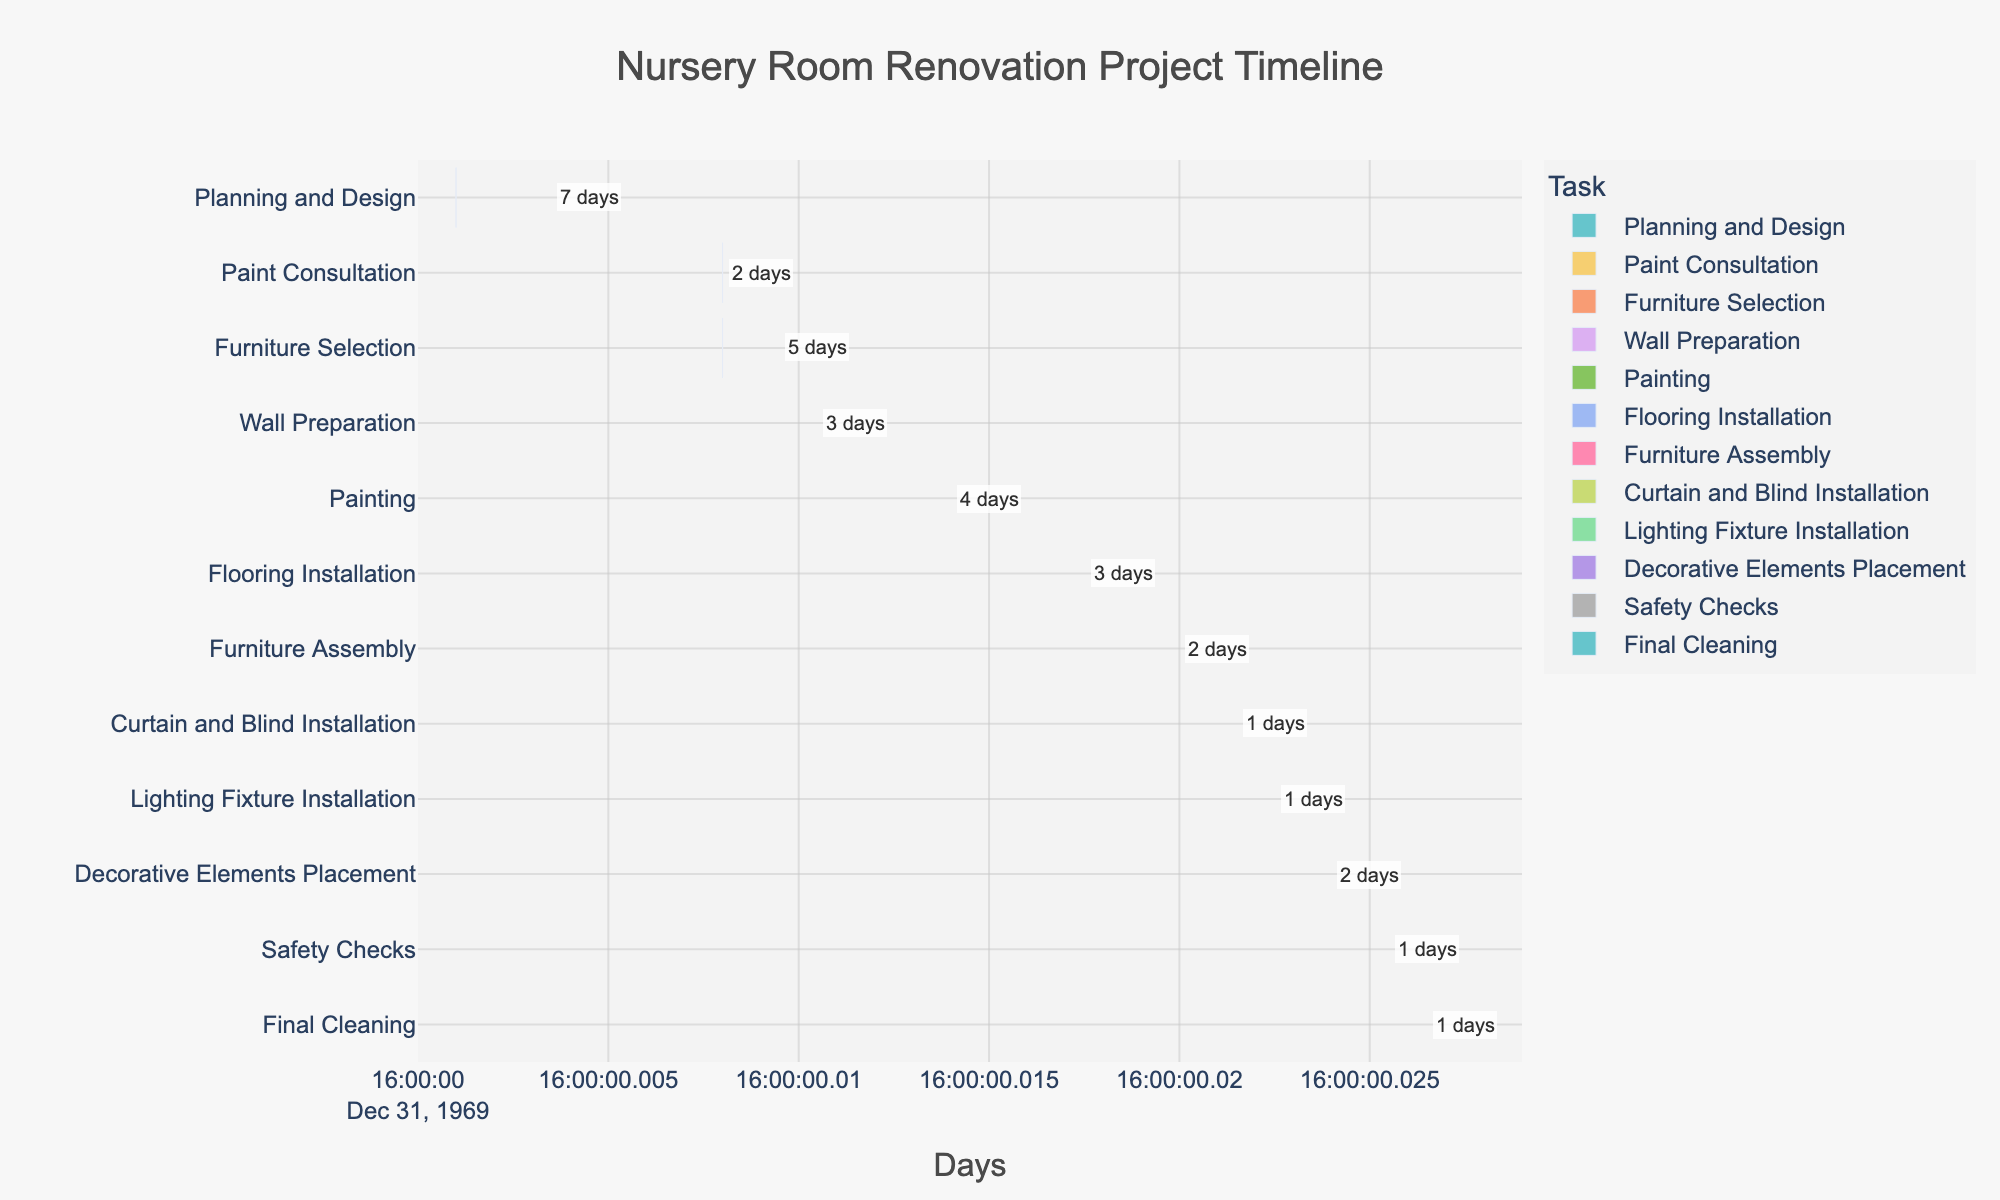What's the title of the figure? The title is displayed at the top of the figure and indicates the overall topic or purpose of the visualization.
Answer: Nursery Room Renovation Project Timeline Which task takes the longest to complete? The durations of each task are annotated in the chart. By comparing these durations, you can identify the longest one.
Answer: Planning and Design How many days does it take from the start of "Wall Preparation" to the completion of "Painting"? "Wall Preparation" starts on day 10 and "Painting" ends on day 17. Calculate the duration by subtracting the start date from the end date: 17 - 10 = 7 days.
Answer: 7 days Which tasks overlap with "Furniture Selection"? "Furniture Selection" occurs from day 8 to day 13. Tasks overlapping with this can be identified by their overlapping timeline bars.
Answer: Paint Consultation and Wall Preparation What is the total duration of the project? The project starts with "Planning and Design" on day 1 and ends with "Final Cleaning" on day 28. Calculate the total duration by subtracting the start day of the first task from the end day of the final task: 28 - 1 + 1 = 28 days.
Answer: 28 days Which tasks are scheduled to start on the same day? Check the start dates for each task and identify any tasks that have the same start date.
Answer: Paint Consultation and Furniture Selection How long does it take to complete both "Lighting Fixture Installation" and "Decorative Elements Placement"? "Lighting Fixture Installation" takes 1 day and "Decorative Elements Placement" takes 2 days. Sum these durations: 1 + 2 = 3 days.
Answer: 3 days Which task is the last to be completed in the project? Identify the task with the latest end date. "Final Cleaning" ends on the last day.
Answer: Final Cleaning When do "Planning and Design" and "Furniture Assembly" end? "Planning and Design" ends on day 8, and "Furniture Assembly" ends on day 22.
Answer: Day 8 and Day 22 